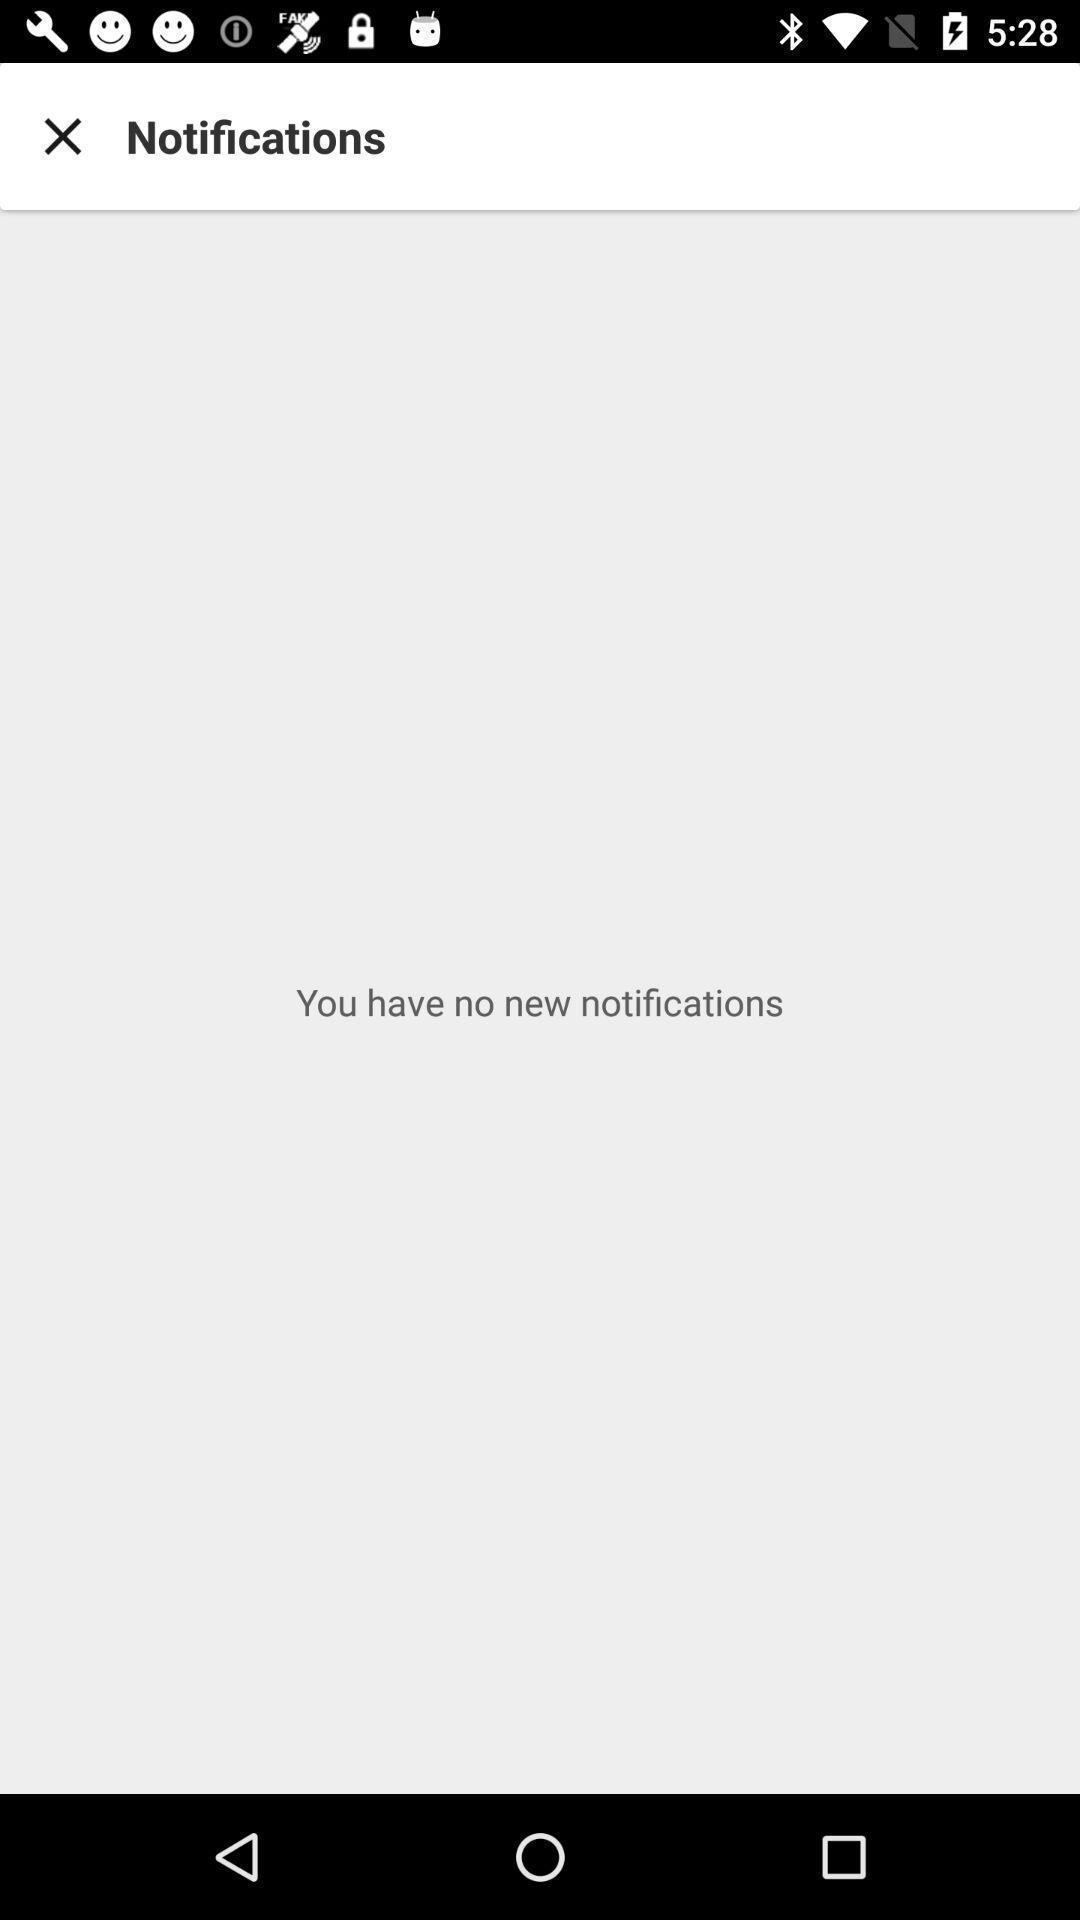Give me a summary of this screen capture. Screen shows no new notifications. 